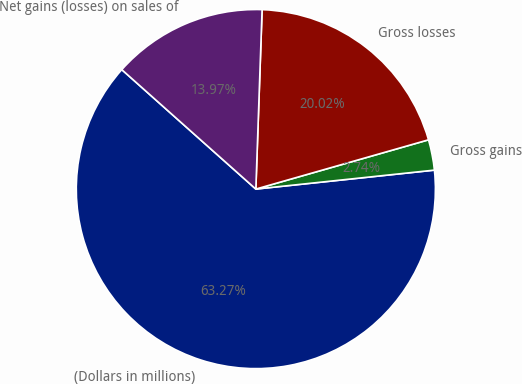Convert chart. <chart><loc_0><loc_0><loc_500><loc_500><pie_chart><fcel>(Dollars in millions)<fcel>Gross gains<fcel>Gross losses<fcel>Net gains (losses) on sales of<nl><fcel>63.26%<fcel>2.74%<fcel>20.02%<fcel>13.97%<nl></chart> 